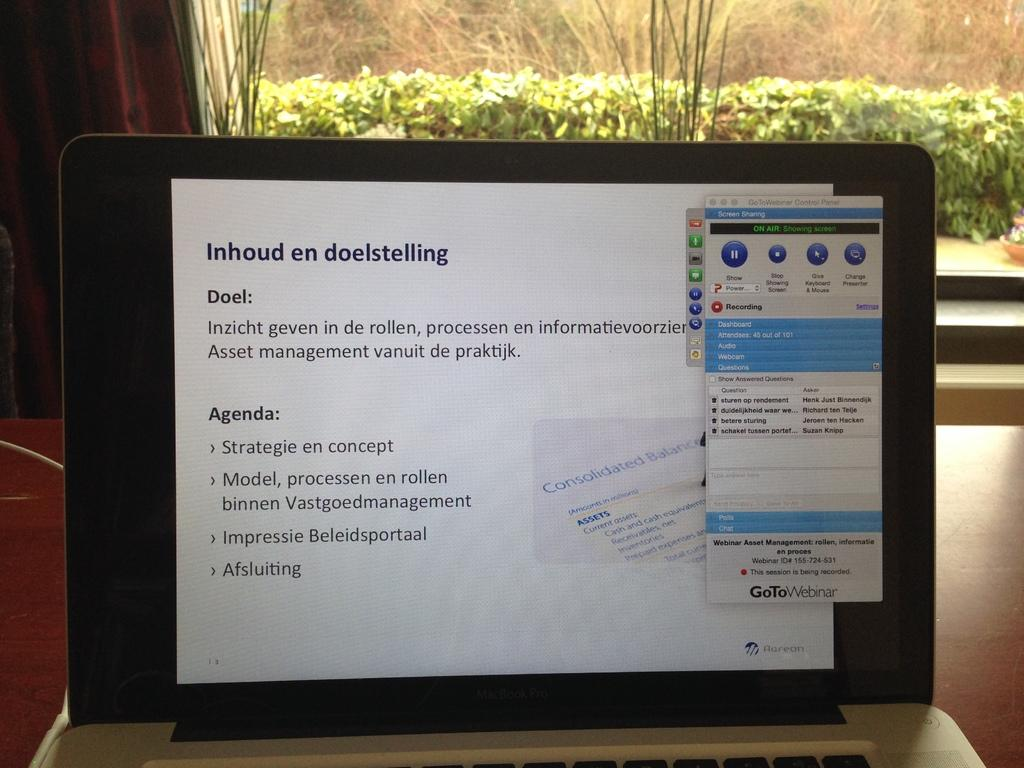Provide a one-sentence caption for the provided image. Inhoud en doelstelling is displayed at the top of the screen of this laptop. 